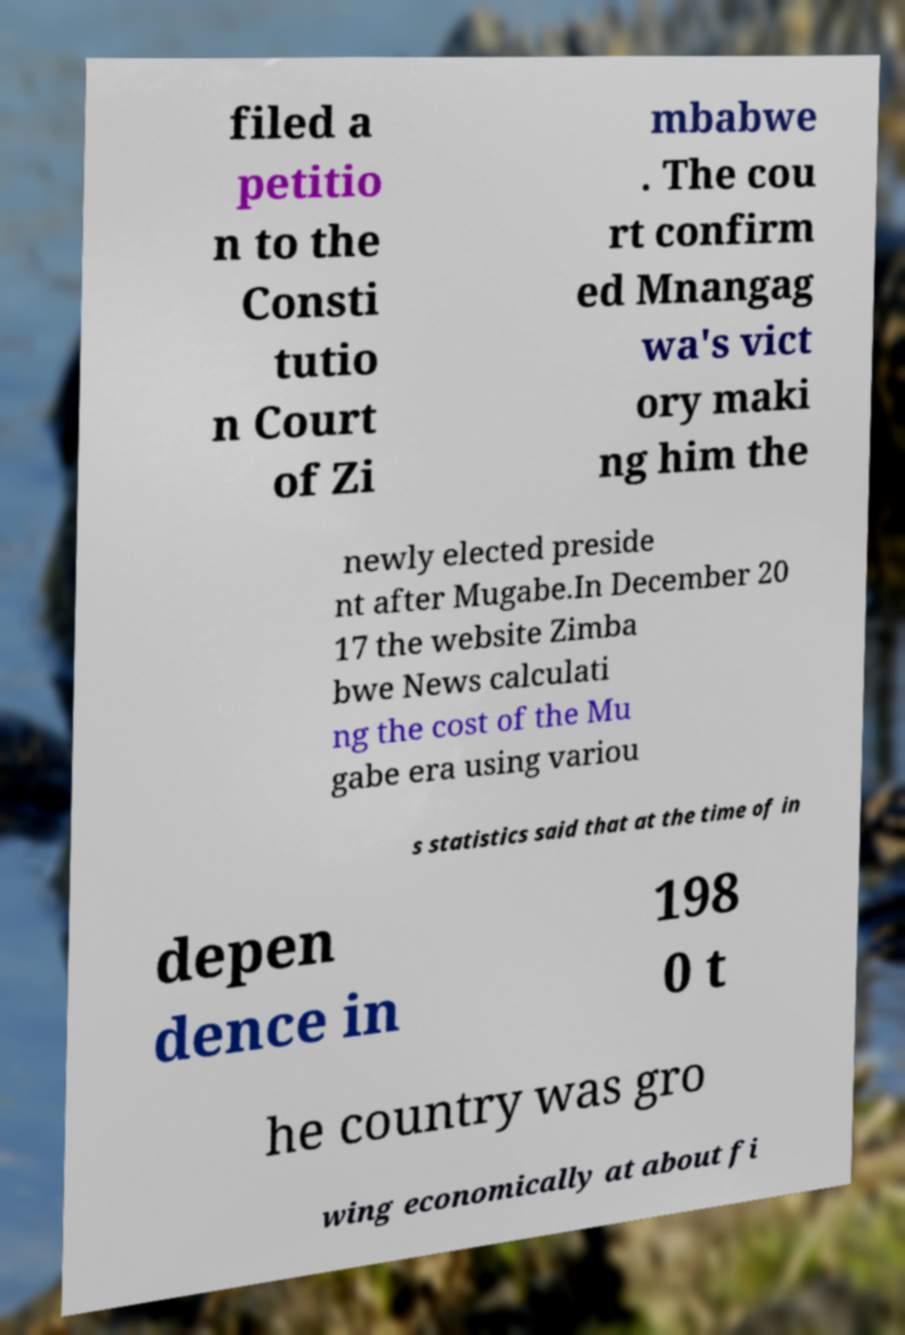I need the written content from this picture converted into text. Can you do that? filed a petitio n to the Consti tutio n Court of Zi mbabwe . The cou rt confirm ed Mnangag wa's vict ory maki ng him the newly elected preside nt after Mugabe.In December 20 17 the website Zimba bwe News calculati ng the cost of the Mu gabe era using variou s statistics said that at the time of in depen dence in 198 0 t he country was gro wing economically at about fi 